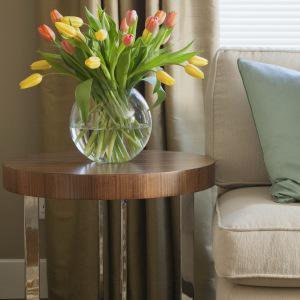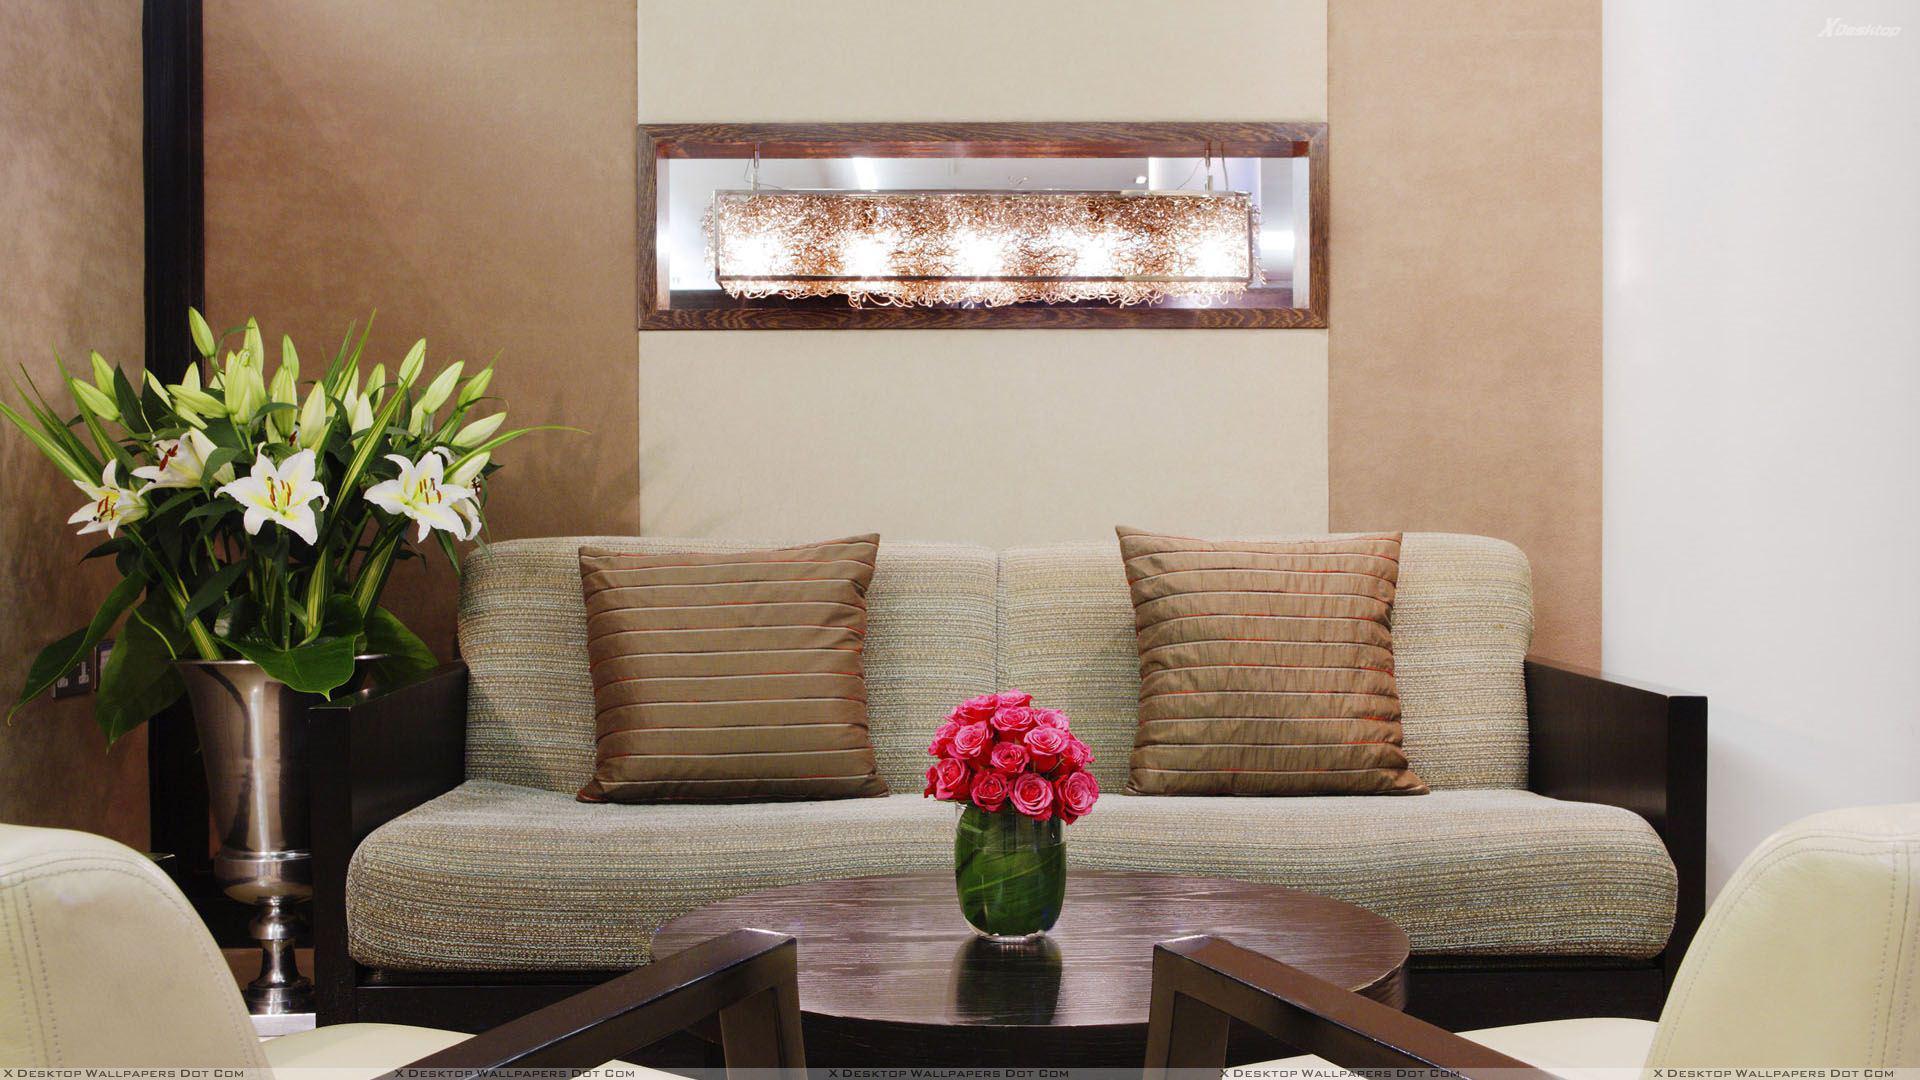The first image is the image on the left, the second image is the image on the right. For the images displayed, is the sentence "A clear glass vase of yellow and orange tulips is near a sofa in front of a window." factually correct? Answer yes or no. Yes. 